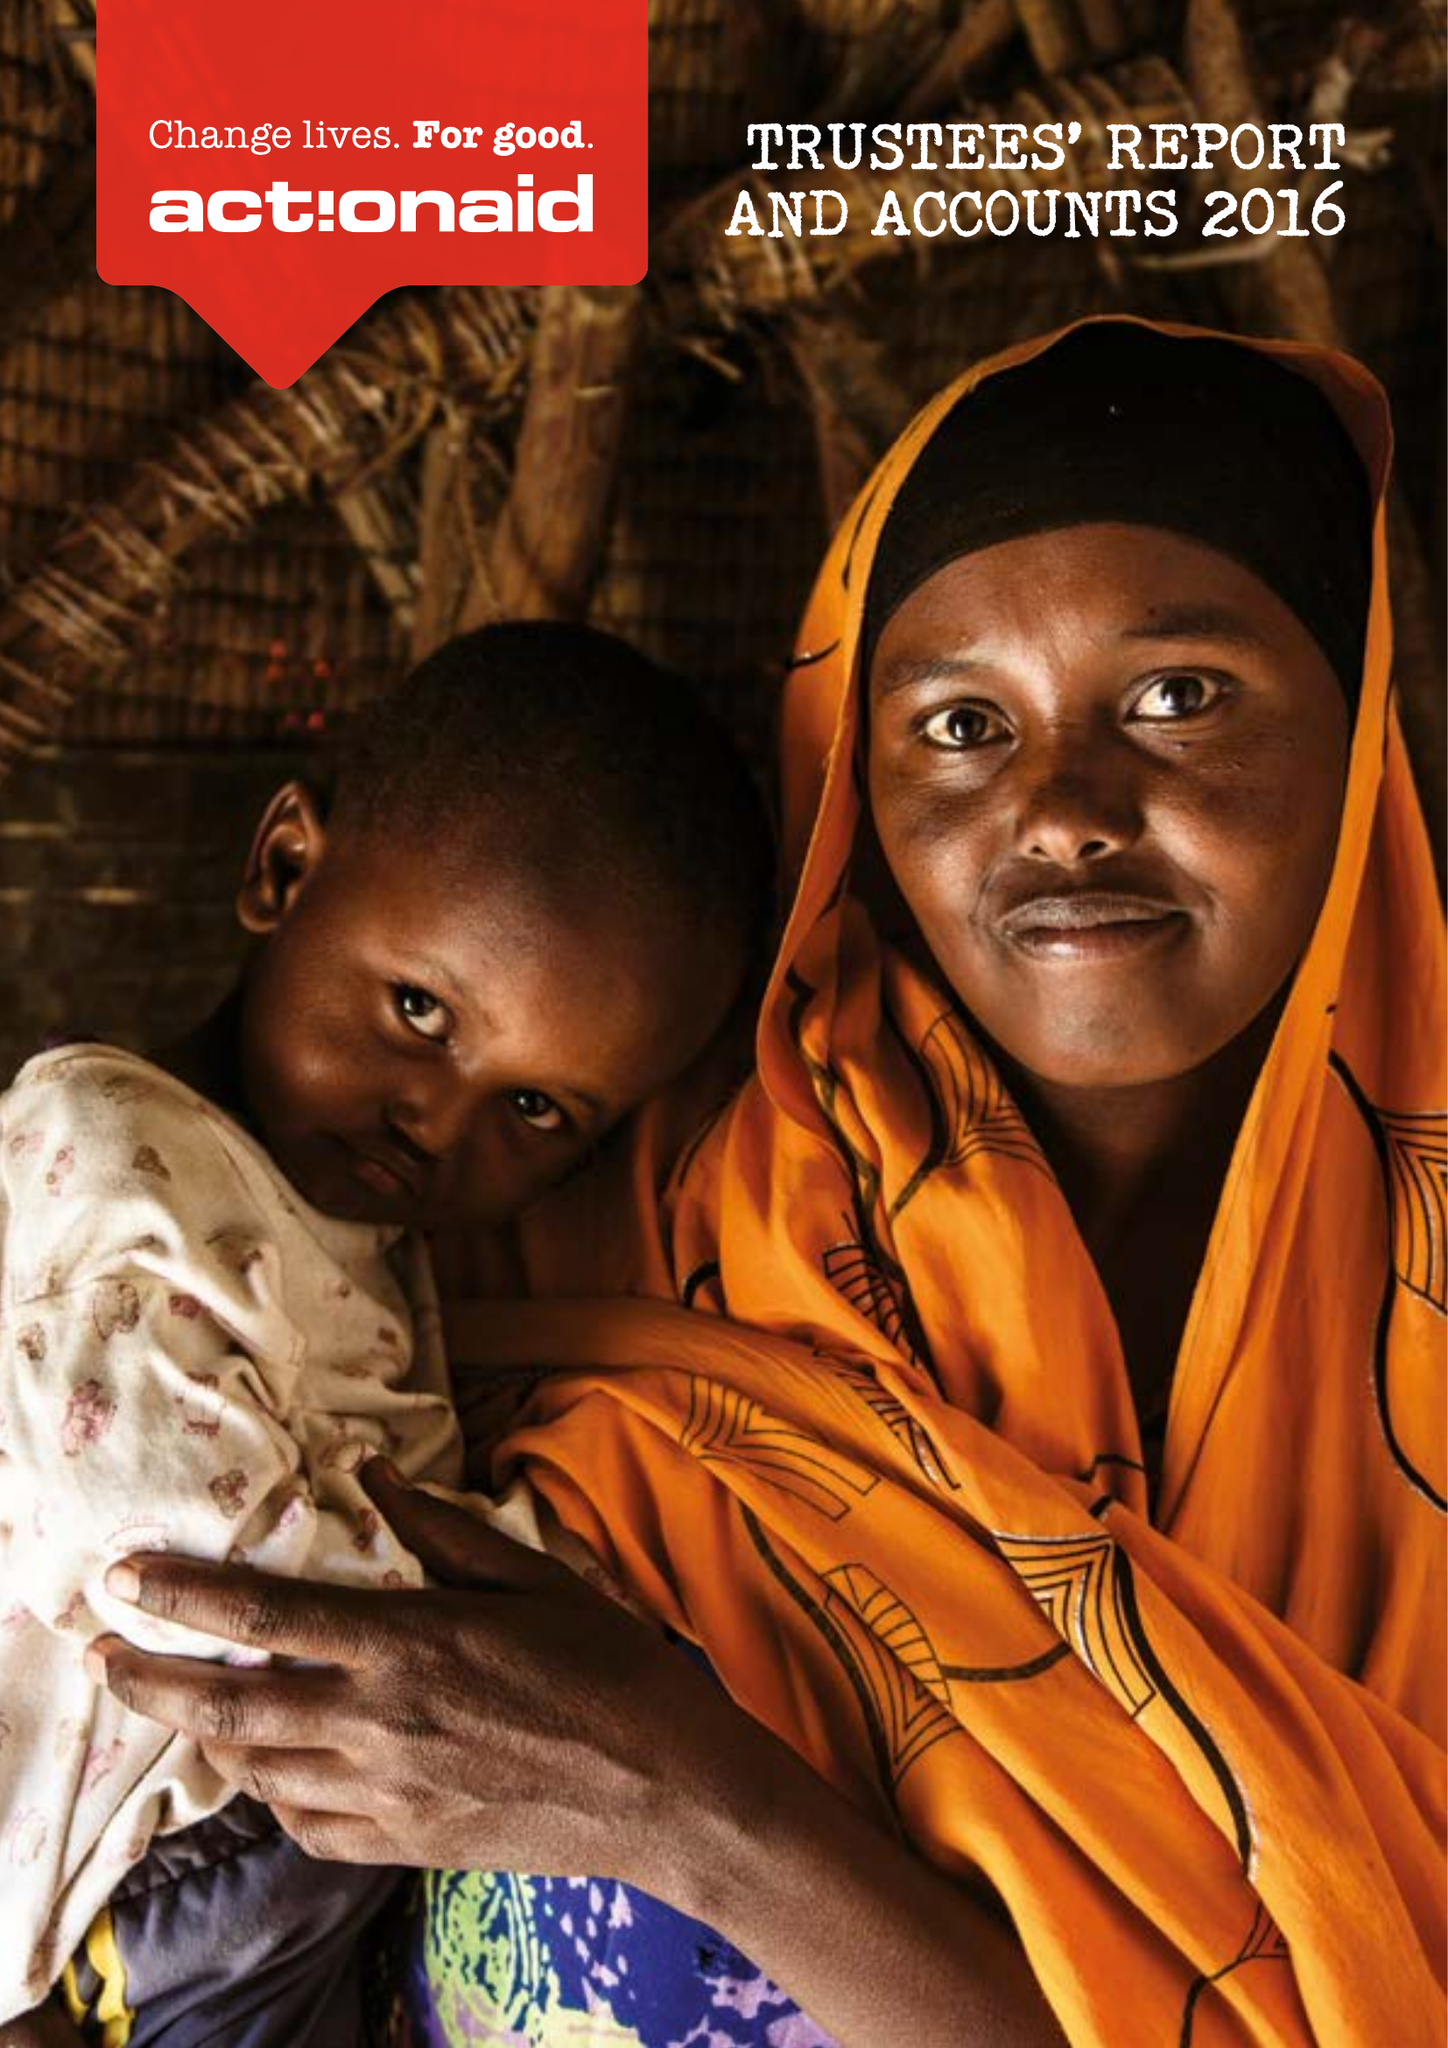What is the value for the address__street_line?
Answer the question using a single word or phrase. 33-39 BOWLING GREEN LANE 